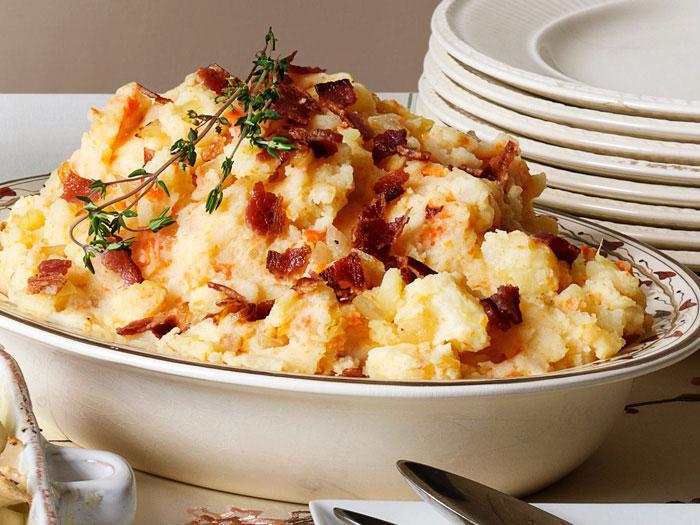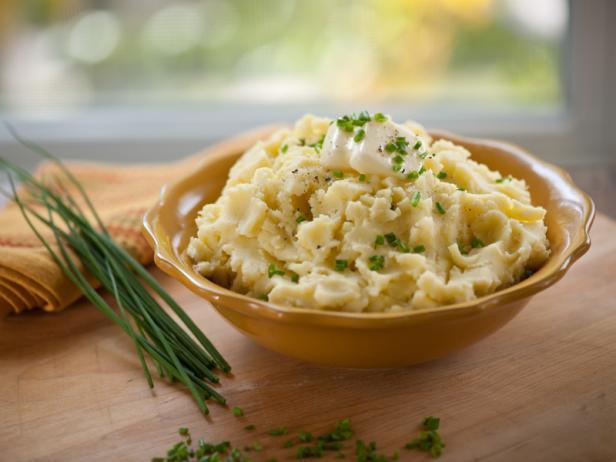The first image is the image on the left, the second image is the image on the right. Evaluate the accuracy of this statement regarding the images: "At least one of the mashed potatoes is not the traditional yellow/orange color.". Is it true? Answer yes or no. No. The first image is the image on the left, the second image is the image on the right. Examine the images to the left and right. Is the description "The right image contains food inside of a bowl." accurate? Answer yes or no. Yes. 